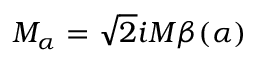<formula> <loc_0><loc_0><loc_500><loc_500>M _ { \alpha } = \sqrt { 2 } i M \beta ( \alpha )</formula> 